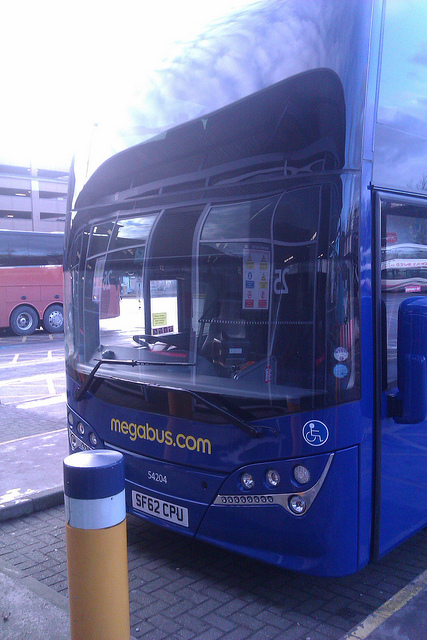Please extract the text content from this image. megabus.com SF62 CPU 